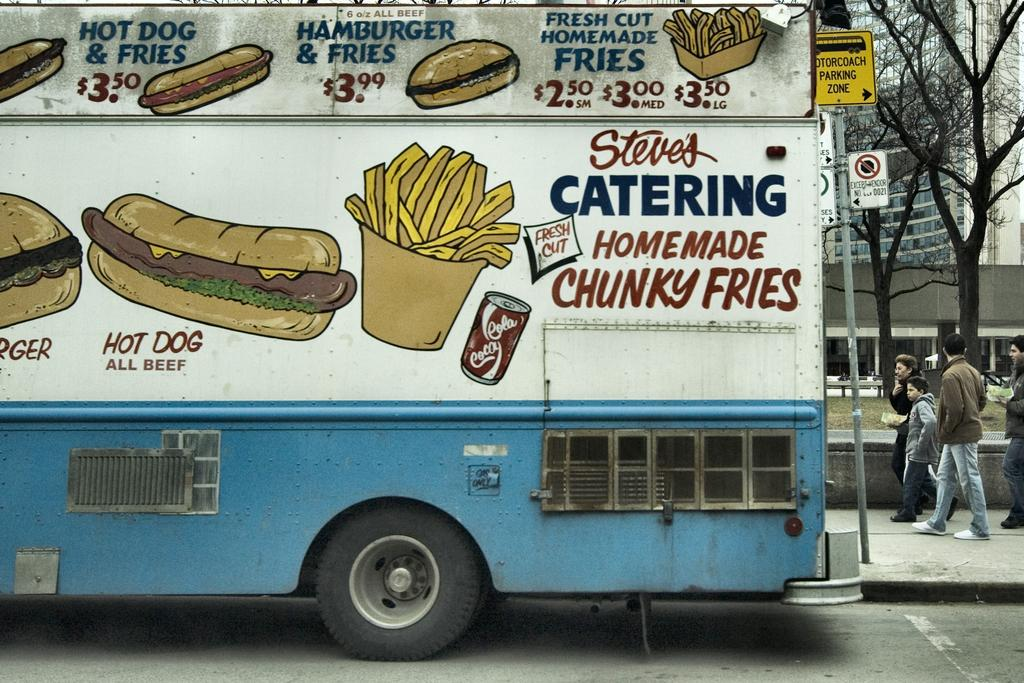What is on the road in the image? There is a vehicle on the road in the image. What are the people in the image doing? The people in the image are walking. What are the people wearing on their feet? The people are wearing shoes. What is present in the image besides the people and the vehicle? There is a pole, a board, trees, grass, and a building in the image. What type of humor can be seen in the image? There is no humor present in the image; it is a scene of people walking, a vehicle on the road, and various other elements. What drug is being used by the people in the image? There is no indication of drug use in the image; the people are simply walking. 